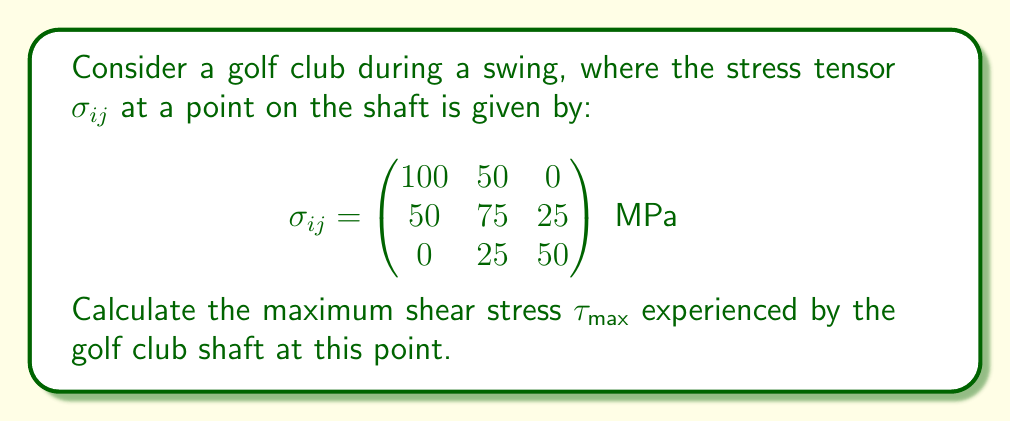Can you solve this math problem? To find the maximum shear stress, we'll follow these steps:

1) First, we need to calculate the principal stresses. These are the eigenvalues of the stress tensor.

2) The characteristic equation for the eigenvalues $\lambda$ is:
   $$\det(\sigma_{ij} - \lambda I) = 0$$

3) Expanding this determinant:
   $$(100-\lambda)(75-\lambda)(50-\lambda) - 50^2(50-\lambda) - 25^2(100-\lambda) = 0$$

4) Simplifying:
   $$\lambda^3 - 225\lambda^2 + 14375\lambda - 218750 = 0$$

5) Solving this cubic equation (typically using a calculator or computer), we get:
   $$\lambda_1 \approx 133.65 \text{ MPa}$$
   $$\lambda_2 \approx 67.18 \text{ MPa}$$
   $$\lambda_3 \approx 24.17 \text{ MPa}$$

6) The maximum shear stress is given by:
   $$\tau_{\text{max}} = \frac{\lambda_1 - \lambda_3}{2}$$

7) Substituting the values:
   $$\tau_{\text{max}} = \frac{133.65 - 24.17}{2} \approx 54.74 \text{ MPa}$$
Answer: $54.74 \text{ MPa}$ 